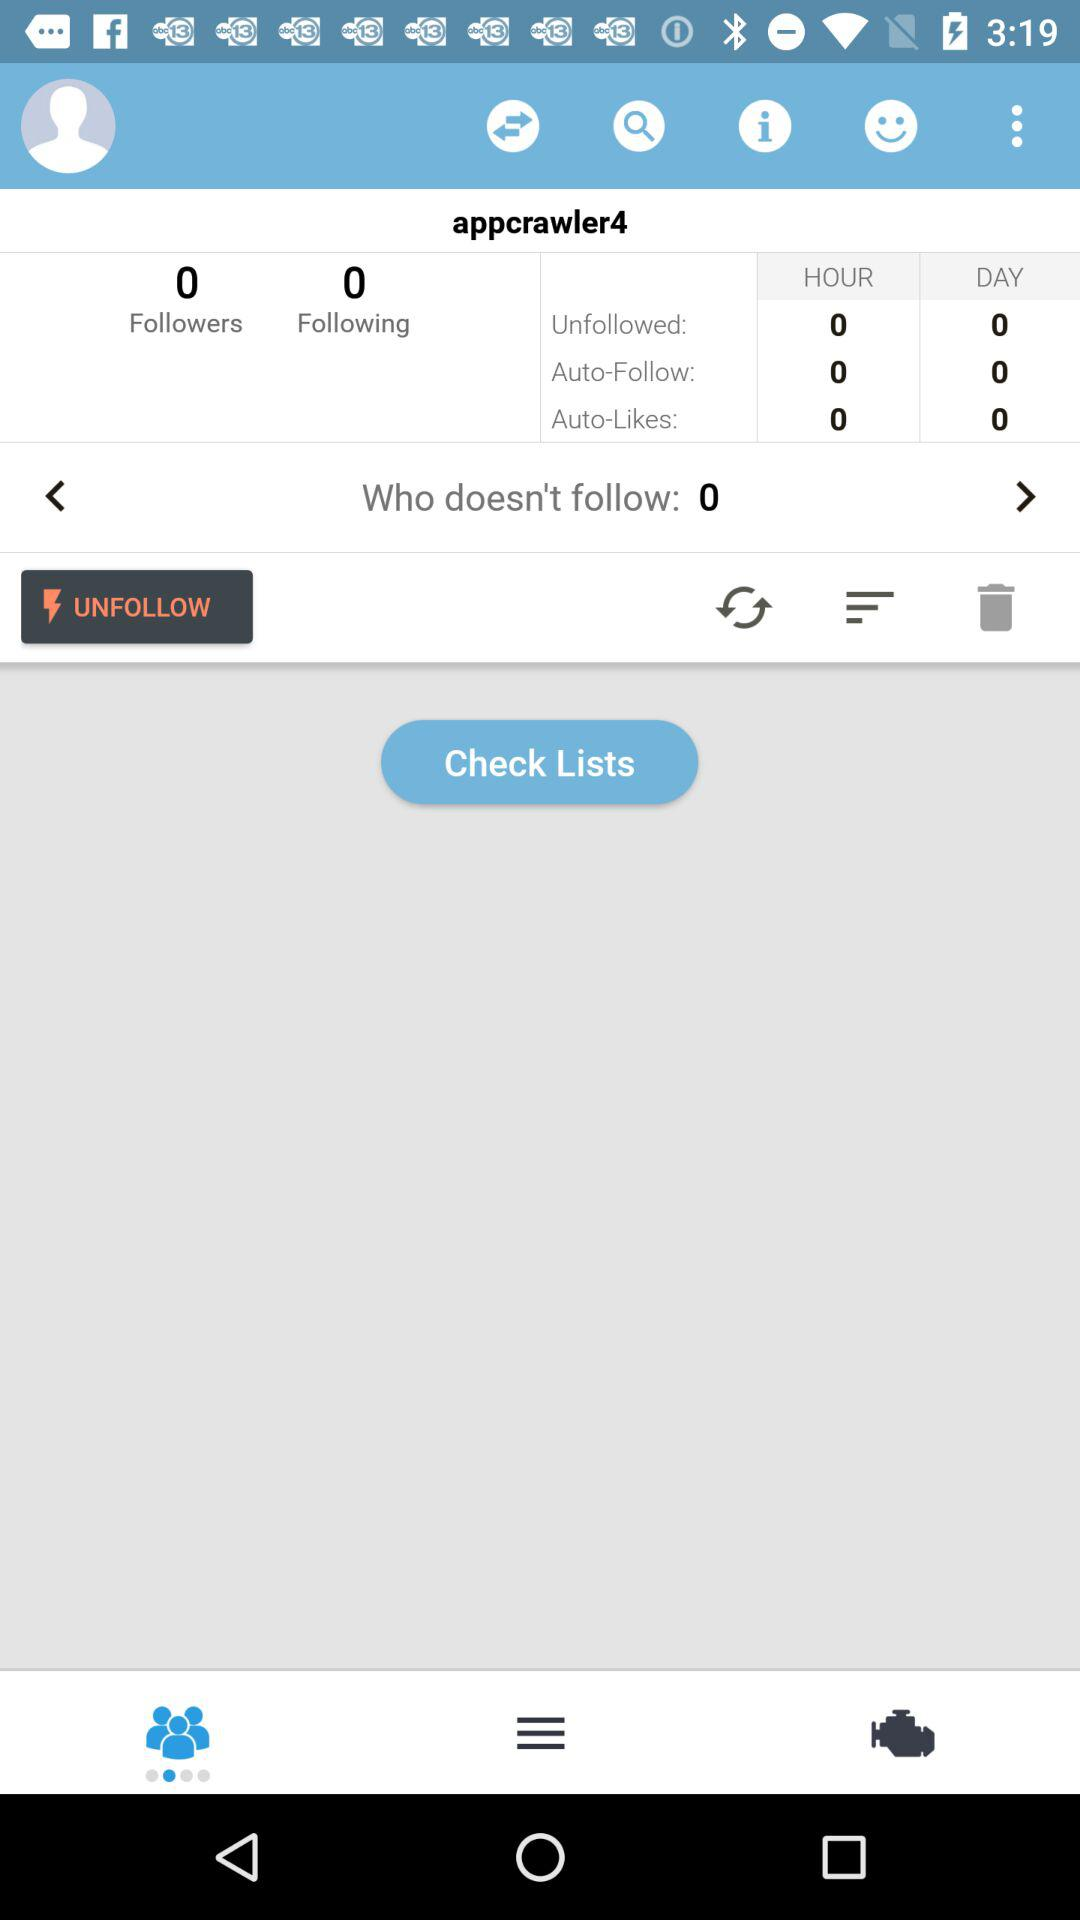How many followers are there? There are 0 followers. 